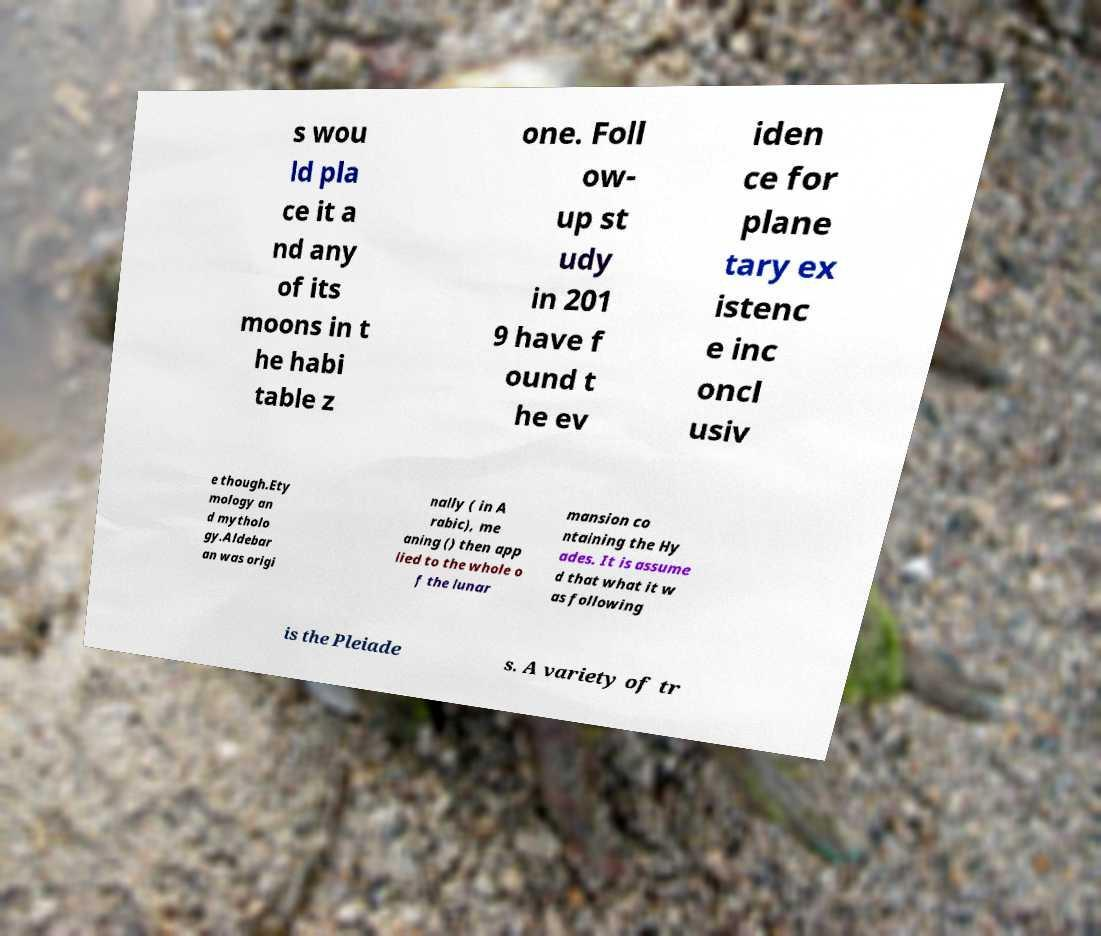Could you extract and type out the text from this image? s wou ld pla ce it a nd any of its moons in t he habi table z one. Foll ow- up st udy in 201 9 have f ound t he ev iden ce for plane tary ex istenc e inc oncl usiv e though.Ety mology an d mytholo gy.Aldebar an was origi nally ( in A rabic), me aning () then app lied to the whole o f the lunar mansion co ntaining the Hy ades. It is assume d that what it w as following is the Pleiade s. A variety of tr 